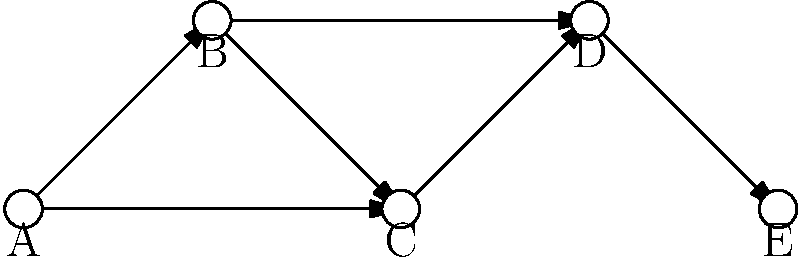In the given node-link diagram representing terrorist communication patterns, which node acts as the primary hub for information dissemination, potentially indicating a key figure in the network? To identify the primary hub for information dissemination in this terrorist communication network, we need to analyze the node-link diagram step-by-step:

1. Count the number of outgoing connections (edges) for each node:
   Node A: 2 outgoing connections
   Node B: 2 outgoing connections
   Node C: 1 outgoing connection
   Node D: 1 outgoing connection
   Node E: 0 outgoing connections

2. Evaluate the position of each node in the network:
   Node A is at the beginning of the network
   Node B is connected to multiple nodes
   Node C is in the middle of the network
   Node D is near the end of the network
   Node E is at the end of the network

3. Analyze the flow of information:
   Information from A can reach all other nodes
   Information from B can reach C, D, and E
   Information from C can only reach D and E
   Information from D can only reach E
   Information from E cannot reach any other node

4. Consider the strategic importance of each node:
   Node A has the most extensive reach and initiates two separate paths
   Node B acts as a secondary hub, connecting to multiple nodes
   Nodes C, D, and E have less significant roles in disseminating information

Based on this analysis, Node A emerges as the primary hub for information dissemination. It has the highest number of outgoing connections and can reach all other nodes in the network, indicating that it likely represents a key figure in the terrorist communication network.
Answer: Node A 